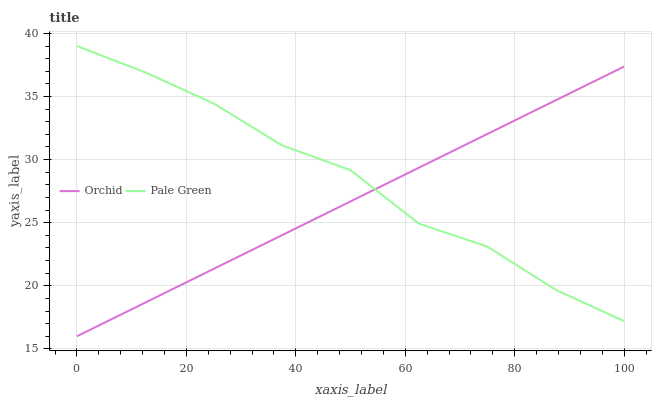Does Orchid have the minimum area under the curve?
Answer yes or no. Yes. Does Pale Green have the maximum area under the curve?
Answer yes or no. Yes. Does Orchid have the maximum area under the curve?
Answer yes or no. No. Is Orchid the smoothest?
Answer yes or no. Yes. Is Pale Green the roughest?
Answer yes or no. Yes. Is Orchid the roughest?
Answer yes or no. No. Does Orchid have the lowest value?
Answer yes or no. Yes. Does Pale Green have the highest value?
Answer yes or no. Yes. Does Orchid have the highest value?
Answer yes or no. No. Does Orchid intersect Pale Green?
Answer yes or no. Yes. Is Orchid less than Pale Green?
Answer yes or no. No. Is Orchid greater than Pale Green?
Answer yes or no. No. 